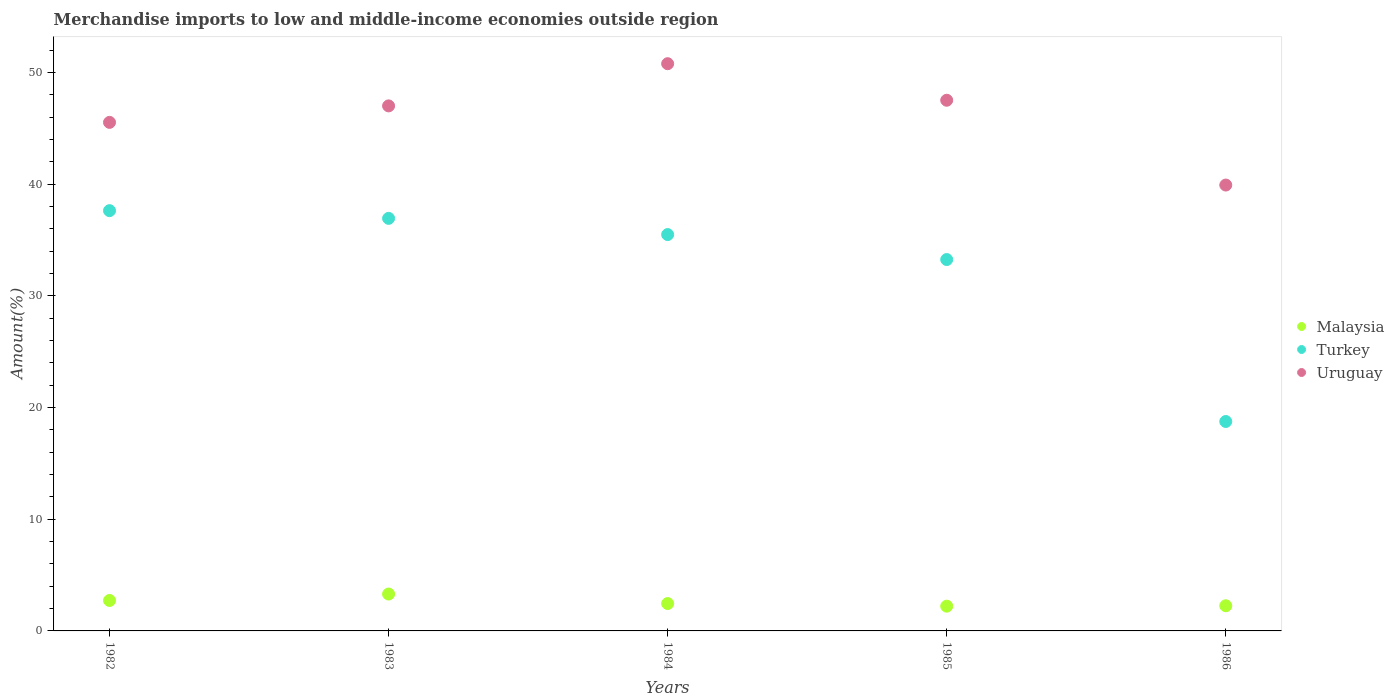Is the number of dotlines equal to the number of legend labels?
Your response must be concise. Yes. What is the percentage of amount earned from merchandise imports in Turkey in 1986?
Keep it short and to the point. 18.75. Across all years, what is the maximum percentage of amount earned from merchandise imports in Turkey?
Provide a succinct answer. 37.62. Across all years, what is the minimum percentage of amount earned from merchandise imports in Malaysia?
Your answer should be compact. 2.21. In which year was the percentage of amount earned from merchandise imports in Malaysia maximum?
Offer a very short reply. 1983. In which year was the percentage of amount earned from merchandise imports in Malaysia minimum?
Provide a succinct answer. 1985. What is the total percentage of amount earned from merchandise imports in Uruguay in the graph?
Give a very brief answer. 230.73. What is the difference between the percentage of amount earned from merchandise imports in Turkey in 1983 and that in 1986?
Offer a very short reply. 18.19. What is the difference between the percentage of amount earned from merchandise imports in Turkey in 1985 and the percentage of amount earned from merchandise imports in Malaysia in 1983?
Offer a terse response. 29.94. What is the average percentage of amount earned from merchandise imports in Malaysia per year?
Your response must be concise. 2.59. In the year 1985, what is the difference between the percentage of amount earned from merchandise imports in Uruguay and percentage of amount earned from merchandise imports in Malaysia?
Keep it short and to the point. 45.29. What is the ratio of the percentage of amount earned from merchandise imports in Malaysia in 1983 to that in 1985?
Keep it short and to the point. 1.49. Is the percentage of amount earned from merchandise imports in Malaysia in 1983 less than that in 1984?
Your response must be concise. No. What is the difference between the highest and the second highest percentage of amount earned from merchandise imports in Turkey?
Offer a terse response. 0.69. What is the difference between the highest and the lowest percentage of amount earned from merchandise imports in Turkey?
Your answer should be compact. 18.87. In how many years, is the percentage of amount earned from merchandise imports in Turkey greater than the average percentage of amount earned from merchandise imports in Turkey taken over all years?
Keep it short and to the point. 4. Is the sum of the percentage of amount earned from merchandise imports in Uruguay in 1982 and 1983 greater than the maximum percentage of amount earned from merchandise imports in Turkey across all years?
Ensure brevity in your answer.  Yes. Does the percentage of amount earned from merchandise imports in Malaysia monotonically increase over the years?
Your answer should be compact. No. Is the percentage of amount earned from merchandise imports in Malaysia strictly greater than the percentage of amount earned from merchandise imports in Uruguay over the years?
Provide a short and direct response. No. Is the percentage of amount earned from merchandise imports in Turkey strictly less than the percentage of amount earned from merchandise imports in Uruguay over the years?
Your response must be concise. Yes. How many years are there in the graph?
Offer a very short reply. 5. Are the values on the major ticks of Y-axis written in scientific E-notation?
Ensure brevity in your answer.  No. Does the graph contain any zero values?
Offer a terse response. No. Does the graph contain grids?
Make the answer very short. No. How are the legend labels stacked?
Ensure brevity in your answer.  Vertical. What is the title of the graph?
Provide a short and direct response. Merchandise imports to low and middle-income economies outside region. What is the label or title of the X-axis?
Your answer should be very brief. Years. What is the label or title of the Y-axis?
Provide a short and direct response. Amount(%). What is the Amount(%) in Malaysia in 1982?
Your answer should be compact. 2.73. What is the Amount(%) in Turkey in 1982?
Make the answer very short. 37.62. What is the Amount(%) in Uruguay in 1982?
Your answer should be compact. 45.53. What is the Amount(%) of Malaysia in 1983?
Provide a succinct answer. 3.3. What is the Amount(%) in Turkey in 1983?
Offer a very short reply. 36.93. What is the Amount(%) in Uruguay in 1983?
Make the answer very short. 47. What is the Amount(%) of Malaysia in 1984?
Ensure brevity in your answer.  2.45. What is the Amount(%) of Turkey in 1984?
Ensure brevity in your answer.  35.48. What is the Amount(%) of Uruguay in 1984?
Keep it short and to the point. 50.78. What is the Amount(%) of Malaysia in 1985?
Offer a terse response. 2.21. What is the Amount(%) in Turkey in 1985?
Give a very brief answer. 33.25. What is the Amount(%) of Uruguay in 1985?
Provide a short and direct response. 47.51. What is the Amount(%) in Malaysia in 1986?
Offer a very short reply. 2.25. What is the Amount(%) of Turkey in 1986?
Offer a terse response. 18.75. What is the Amount(%) in Uruguay in 1986?
Your answer should be compact. 39.92. Across all years, what is the maximum Amount(%) in Malaysia?
Your answer should be compact. 3.3. Across all years, what is the maximum Amount(%) in Turkey?
Make the answer very short. 37.62. Across all years, what is the maximum Amount(%) of Uruguay?
Your answer should be compact. 50.78. Across all years, what is the minimum Amount(%) of Malaysia?
Provide a short and direct response. 2.21. Across all years, what is the minimum Amount(%) in Turkey?
Your response must be concise. 18.75. Across all years, what is the minimum Amount(%) of Uruguay?
Provide a succinct answer. 39.92. What is the total Amount(%) of Malaysia in the graph?
Provide a succinct answer. 12.95. What is the total Amount(%) of Turkey in the graph?
Provide a succinct answer. 162.03. What is the total Amount(%) in Uruguay in the graph?
Offer a very short reply. 230.73. What is the difference between the Amount(%) in Malaysia in 1982 and that in 1983?
Your answer should be compact. -0.57. What is the difference between the Amount(%) of Turkey in 1982 and that in 1983?
Keep it short and to the point. 0.69. What is the difference between the Amount(%) of Uruguay in 1982 and that in 1983?
Make the answer very short. -1.48. What is the difference between the Amount(%) in Malaysia in 1982 and that in 1984?
Your answer should be compact. 0.28. What is the difference between the Amount(%) of Turkey in 1982 and that in 1984?
Provide a succinct answer. 2.14. What is the difference between the Amount(%) in Uruguay in 1982 and that in 1984?
Offer a very short reply. -5.25. What is the difference between the Amount(%) of Malaysia in 1982 and that in 1985?
Your answer should be very brief. 0.51. What is the difference between the Amount(%) in Turkey in 1982 and that in 1985?
Your answer should be compact. 4.38. What is the difference between the Amount(%) of Uruguay in 1982 and that in 1985?
Your answer should be very brief. -1.98. What is the difference between the Amount(%) of Malaysia in 1982 and that in 1986?
Your answer should be very brief. 0.48. What is the difference between the Amount(%) of Turkey in 1982 and that in 1986?
Give a very brief answer. 18.87. What is the difference between the Amount(%) in Uruguay in 1982 and that in 1986?
Your answer should be compact. 5.61. What is the difference between the Amount(%) in Malaysia in 1983 and that in 1984?
Provide a succinct answer. 0.85. What is the difference between the Amount(%) of Turkey in 1983 and that in 1984?
Keep it short and to the point. 1.45. What is the difference between the Amount(%) in Uruguay in 1983 and that in 1984?
Your response must be concise. -3.78. What is the difference between the Amount(%) of Malaysia in 1983 and that in 1985?
Provide a short and direct response. 1.09. What is the difference between the Amount(%) of Turkey in 1983 and that in 1985?
Offer a very short reply. 3.69. What is the difference between the Amount(%) of Uruguay in 1983 and that in 1985?
Provide a short and direct response. -0.51. What is the difference between the Amount(%) in Malaysia in 1983 and that in 1986?
Provide a short and direct response. 1.05. What is the difference between the Amount(%) in Turkey in 1983 and that in 1986?
Offer a terse response. 18.19. What is the difference between the Amount(%) of Uruguay in 1983 and that in 1986?
Make the answer very short. 7.09. What is the difference between the Amount(%) in Malaysia in 1984 and that in 1985?
Provide a succinct answer. 0.24. What is the difference between the Amount(%) of Turkey in 1984 and that in 1985?
Offer a terse response. 2.24. What is the difference between the Amount(%) in Uruguay in 1984 and that in 1985?
Provide a short and direct response. 3.27. What is the difference between the Amount(%) of Malaysia in 1984 and that in 1986?
Give a very brief answer. 0.2. What is the difference between the Amount(%) of Turkey in 1984 and that in 1986?
Provide a short and direct response. 16.73. What is the difference between the Amount(%) of Uruguay in 1984 and that in 1986?
Your answer should be very brief. 10.86. What is the difference between the Amount(%) of Malaysia in 1985 and that in 1986?
Your answer should be very brief. -0.04. What is the difference between the Amount(%) in Turkey in 1985 and that in 1986?
Provide a succinct answer. 14.5. What is the difference between the Amount(%) in Uruguay in 1985 and that in 1986?
Provide a short and direct response. 7.59. What is the difference between the Amount(%) in Malaysia in 1982 and the Amount(%) in Turkey in 1983?
Make the answer very short. -34.21. What is the difference between the Amount(%) of Malaysia in 1982 and the Amount(%) of Uruguay in 1983?
Make the answer very short. -44.27. What is the difference between the Amount(%) of Turkey in 1982 and the Amount(%) of Uruguay in 1983?
Provide a succinct answer. -9.38. What is the difference between the Amount(%) in Malaysia in 1982 and the Amount(%) in Turkey in 1984?
Keep it short and to the point. -32.75. What is the difference between the Amount(%) in Malaysia in 1982 and the Amount(%) in Uruguay in 1984?
Keep it short and to the point. -48.05. What is the difference between the Amount(%) of Turkey in 1982 and the Amount(%) of Uruguay in 1984?
Ensure brevity in your answer.  -13.16. What is the difference between the Amount(%) of Malaysia in 1982 and the Amount(%) of Turkey in 1985?
Your response must be concise. -30.52. What is the difference between the Amount(%) of Malaysia in 1982 and the Amount(%) of Uruguay in 1985?
Your response must be concise. -44.78. What is the difference between the Amount(%) in Turkey in 1982 and the Amount(%) in Uruguay in 1985?
Your answer should be compact. -9.88. What is the difference between the Amount(%) of Malaysia in 1982 and the Amount(%) of Turkey in 1986?
Your response must be concise. -16.02. What is the difference between the Amount(%) of Malaysia in 1982 and the Amount(%) of Uruguay in 1986?
Ensure brevity in your answer.  -37.19. What is the difference between the Amount(%) of Turkey in 1982 and the Amount(%) of Uruguay in 1986?
Offer a very short reply. -2.29. What is the difference between the Amount(%) of Malaysia in 1983 and the Amount(%) of Turkey in 1984?
Offer a very short reply. -32.18. What is the difference between the Amount(%) in Malaysia in 1983 and the Amount(%) in Uruguay in 1984?
Provide a succinct answer. -47.48. What is the difference between the Amount(%) of Turkey in 1983 and the Amount(%) of Uruguay in 1984?
Offer a terse response. -13.85. What is the difference between the Amount(%) of Malaysia in 1983 and the Amount(%) of Turkey in 1985?
Offer a very short reply. -29.94. What is the difference between the Amount(%) in Malaysia in 1983 and the Amount(%) in Uruguay in 1985?
Provide a succinct answer. -44.21. What is the difference between the Amount(%) of Turkey in 1983 and the Amount(%) of Uruguay in 1985?
Make the answer very short. -10.57. What is the difference between the Amount(%) of Malaysia in 1983 and the Amount(%) of Turkey in 1986?
Offer a very short reply. -15.45. What is the difference between the Amount(%) in Malaysia in 1983 and the Amount(%) in Uruguay in 1986?
Your answer should be compact. -36.61. What is the difference between the Amount(%) of Turkey in 1983 and the Amount(%) of Uruguay in 1986?
Make the answer very short. -2.98. What is the difference between the Amount(%) of Malaysia in 1984 and the Amount(%) of Turkey in 1985?
Your answer should be compact. -30.8. What is the difference between the Amount(%) of Malaysia in 1984 and the Amount(%) of Uruguay in 1985?
Provide a succinct answer. -45.06. What is the difference between the Amount(%) in Turkey in 1984 and the Amount(%) in Uruguay in 1985?
Your response must be concise. -12.03. What is the difference between the Amount(%) in Malaysia in 1984 and the Amount(%) in Turkey in 1986?
Your answer should be very brief. -16.3. What is the difference between the Amount(%) in Malaysia in 1984 and the Amount(%) in Uruguay in 1986?
Offer a very short reply. -37.47. What is the difference between the Amount(%) in Turkey in 1984 and the Amount(%) in Uruguay in 1986?
Give a very brief answer. -4.43. What is the difference between the Amount(%) of Malaysia in 1985 and the Amount(%) of Turkey in 1986?
Provide a succinct answer. -16.53. What is the difference between the Amount(%) of Malaysia in 1985 and the Amount(%) of Uruguay in 1986?
Your response must be concise. -37.7. What is the difference between the Amount(%) of Turkey in 1985 and the Amount(%) of Uruguay in 1986?
Make the answer very short. -6.67. What is the average Amount(%) of Malaysia per year?
Your answer should be compact. 2.59. What is the average Amount(%) in Turkey per year?
Your answer should be compact. 32.41. What is the average Amount(%) in Uruguay per year?
Offer a terse response. 46.15. In the year 1982, what is the difference between the Amount(%) of Malaysia and Amount(%) of Turkey?
Keep it short and to the point. -34.9. In the year 1982, what is the difference between the Amount(%) of Malaysia and Amount(%) of Uruguay?
Provide a short and direct response. -42.8. In the year 1982, what is the difference between the Amount(%) of Turkey and Amount(%) of Uruguay?
Your answer should be very brief. -7.9. In the year 1983, what is the difference between the Amount(%) in Malaysia and Amount(%) in Turkey?
Ensure brevity in your answer.  -33.63. In the year 1983, what is the difference between the Amount(%) of Malaysia and Amount(%) of Uruguay?
Your response must be concise. -43.7. In the year 1983, what is the difference between the Amount(%) of Turkey and Amount(%) of Uruguay?
Give a very brief answer. -10.07. In the year 1984, what is the difference between the Amount(%) of Malaysia and Amount(%) of Turkey?
Provide a succinct answer. -33.03. In the year 1984, what is the difference between the Amount(%) in Malaysia and Amount(%) in Uruguay?
Keep it short and to the point. -48.33. In the year 1984, what is the difference between the Amount(%) of Turkey and Amount(%) of Uruguay?
Ensure brevity in your answer.  -15.3. In the year 1985, what is the difference between the Amount(%) in Malaysia and Amount(%) in Turkey?
Make the answer very short. -31.03. In the year 1985, what is the difference between the Amount(%) in Malaysia and Amount(%) in Uruguay?
Ensure brevity in your answer.  -45.29. In the year 1985, what is the difference between the Amount(%) in Turkey and Amount(%) in Uruguay?
Offer a very short reply. -14.26. In the year 1986, what is the difference between the Amount(%) in Malaysia and Amount(%) in Turkey?
Offer a terse response. -16.5. In the year 1986, what is the difference between the Amount(%) of Malaysia and Amount(%) of Uruguay?
Make the answer very short. -37.66. In the year 1986, what is the difference between the Amount(%) of Turkey and Amount(%) of Uruguay?
Keep it short and to the point. -21.17. What is the ratio of the Amount(%) of Malaysia in 1982 to that in 1983?
Provide a short and direct response. 0.83. What is the ratio of the Amount(%) in Turkey in 1982 to that in 1983?
Offer a very short reply. 1.02. What is the ratio of the Amount(%) of Uruguay in 1982 to that in 1983?
Offer a very short reply. 0.97. What is the ratio of the Amount(%) of Malaysia in 1982 to that in 1984?
Your response must be concise. 1.11. What is the ratio of the Amount(%) in Turkey in 1982 to that in 1984?
Your response must be concise. 1.06. What is the ratio of the Amount(%) of Uruguay in 1982 to that in 1984?
Your answer should be compact. 0.9. What is the ratio of the Amount(%) of Malaysia in 1982 to that in 1985?
Give a very brief answer. 1.23. What is the ratio of the Amount(%) in Turkey in 1982 to that in 1985?
Provide a short and direct response. 1.13. What is the ratio of the Amount(%) of Uruguay in 1982 to that in 1985?
Your response must be concise. 0.96. What is the ratio of the Amount(%) of Malaysia in 1982 to that in 1986?
Offer a terse response. 1.21. What is the ratio of the Amount(%) of Turkey in 1982 to that in 1986?
Ensure brevity in your answer.  2.01. What is the ratio of the Amount(%) of Uruguay in 1982 to that in 1986?
Your answer should be compact. 1.14. What is the ratio of the Amount(%) in Malaysia in 1983 to that in 1984?
Give a very brief answer. 1.35. What is the ratio of the Amount(%) in Turkey in 1983 to that in 1984?
Provide a short and direct response. 1.04. What is the ratio of the Amount(%) in Uruguay in 1983 to that in 1984?
Keep it short and to the point. 0.93. What is the ratio of the Amount(%) of Malaysia in 1983 to that in 1985?
Keep it short and to the point. 1.49. What is the ratio of the Amount(%) in Turkey in 1983 to that in 1985?
Your response must be concise. 1.11. What is the ratio of the Amount(%) in Uruguay in 1983 to that in 1985?
Give a very brief answer. 0.99. What is the ratio of the Amount(%) in Malaysia in 1983 to that in 1986?
Provide a succinct answer. 1.47. What is the ratio of the Amount(%) of Turkey in 1983 to that in 1986?
Give a very brief answer. 1.97. What is the ratio of the Amount(%) in Uruguay in 1983 to that in 1986?
Give a very brief answer. 1.18. What is the ratio of the Amount(%) of Malaysia in 1984 to that in 1985?
Your answer should be compact. 1.11. What is the ratio of the Amount(%) in Turkey in 1984 to that in 1985?
Make the answer very short. 1.07. What is the ratio of the Amount(%) of Uruguay in 1984 to that in 1985?
Your response must be concise. 1.07. What is the ratio of the Amount(%) of Malaysia in 1984 to that in 1986?
Provide a short and direct response. 1.09. What is the ratio of the Amount(%) of Turkey in 1984 to that in 1986?
Your response must be concise. 1.89. What is the ratio of the Amount(%) in Uruguay in 1984 to that in 1986?
Ensure brevity in your answer.  1.27. What is the ratio of the Amount(%) of Malaysia in 1985 to that in 1986?
Ensure brevity in your answer.  0.98. What is the ratio of the Amount(%) in Turkey in 1985 to that in 1986?
Your answer should be compact. 1.77. What is the ratio of the Amount(%) in Uruguay in 1985 to that in 1986?
Provide a short and direct response. 1.19. What is the difference between the highest and the second highest Amount(%) in Malaysia?
Make the answer very short. 0.57. What is the difference between the highest and the second highest Amount(%) in Turkey?
Keep it short and to the point. 0.69. What is the difference between the highest and the second highest Amount(%) in Uruguay?
Offer a very short reply. 3.27. What is the difference between the highest and the lowest Amount(%) in Malaysia?
Provide a short and direct response. 1.09. What is the difference between the highest and the lowest Amount(%) in Turkey?
Give a very brief answer. 18.87. What is the difference between the highest and the lowest Amount(%) of Uruguay?
Provide a short and direct response. 10.86. 